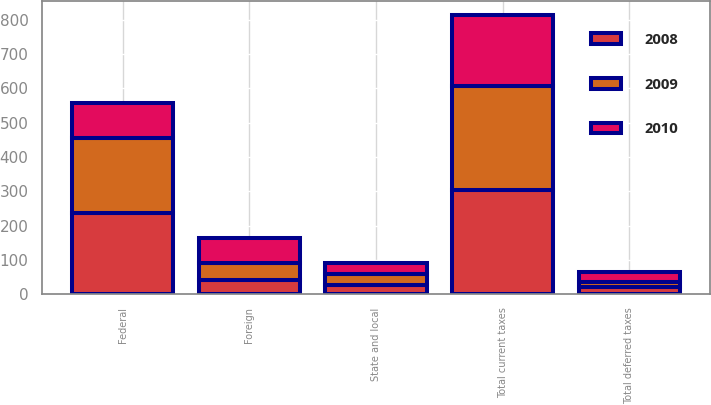Convert chart. <chart><loc_0><loc_0><loc_500><loc_500><stacked_bar_chart><ecel><fcel>Federal<fcel>State and local<fcel>Foreign<fcel>Total current taxes<fcel>Total deferred taxes<nl><fcel>2010<fcel>103.6<fcel>30.1<fcel>73<fcel>206.7<fcel>28.6<nl><fcel>2008<fcel>235.8<fcel>26<fcel>41.8<fcel>303.6<fcel>20.9<nl><fcel>2009<fcel>219.6<fcel>34.5<fcel>49.7<fcel>303.8<fcel>15.9<nl></chart> 